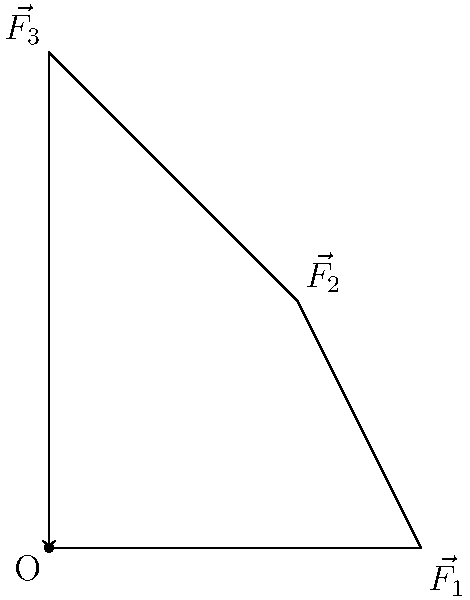In a psychology experiment studying the effects of physical forces on perception, three forces are applied to a point O as shown in the diagram. Force $\vec{F_1}$ has a magnitude of 3 units and is directed along the positive x-axis, $\vec{F_2}$ has a magnitude of 2$\sqrt{2}$ units at 45° to the x-axis, and $\vec{F_3}$ has a magnitude of 4 units along the positive y-axis. Calculate the magnitude and direction (angle with respect to the positive x-axis) of the resultant force vector. To find the resultant force vector, we need to add the three force vectors and then calculate its magnitude and direction. Let's follow these steps:

1) First, let's break down $\vec{F_2}$ into its x and y components:
   $F_{2x} = 2\sqrt{2} \cos 45° = 2$ units
   $F_{2y} = 2\sqrt{2} \sin 45° = 2$ units

2) Now, we can sum up the x and y components of all forces:
   $R_x = F_{1x} + F_{2x} + F_{3x} = 3 + 2 + 0 = 5$ units
   $R_y = F_{1y} + F_{2y} + F_{3y} = 0 + 2 + 4 = 6$ units

3) The resultant force vector $\vec{R}$ has components (5, 6).

4) To find the magnitude of $\vec{R}$, we use the Pythagorean theorem:
   $|\vec{R}| = \sqrt{R_x^2 + R_y^2} = \sqrt{5^2 + 6^2} = \sqrt{61} \approx 7.81$ units

5) To find the direction, we calculate the angle $\theta$ using the arctangent function:
   $\theta = \tan^{-1}(\frac{R_y}{R_x}) = \tan^{-1}(\frac{6}{5}) \approx 50.2°$

Therefore, the resultant force vector has a magnitude of approximately 7.81 units and is directed at an angle of about 50.2° from the positive x-axis.
Answer: Magnitude: $\sqrt{61}$ units (≈7.81 units), Direction: $\tan^{-1}(\frac{6}{5})$ (≈50.2°) 